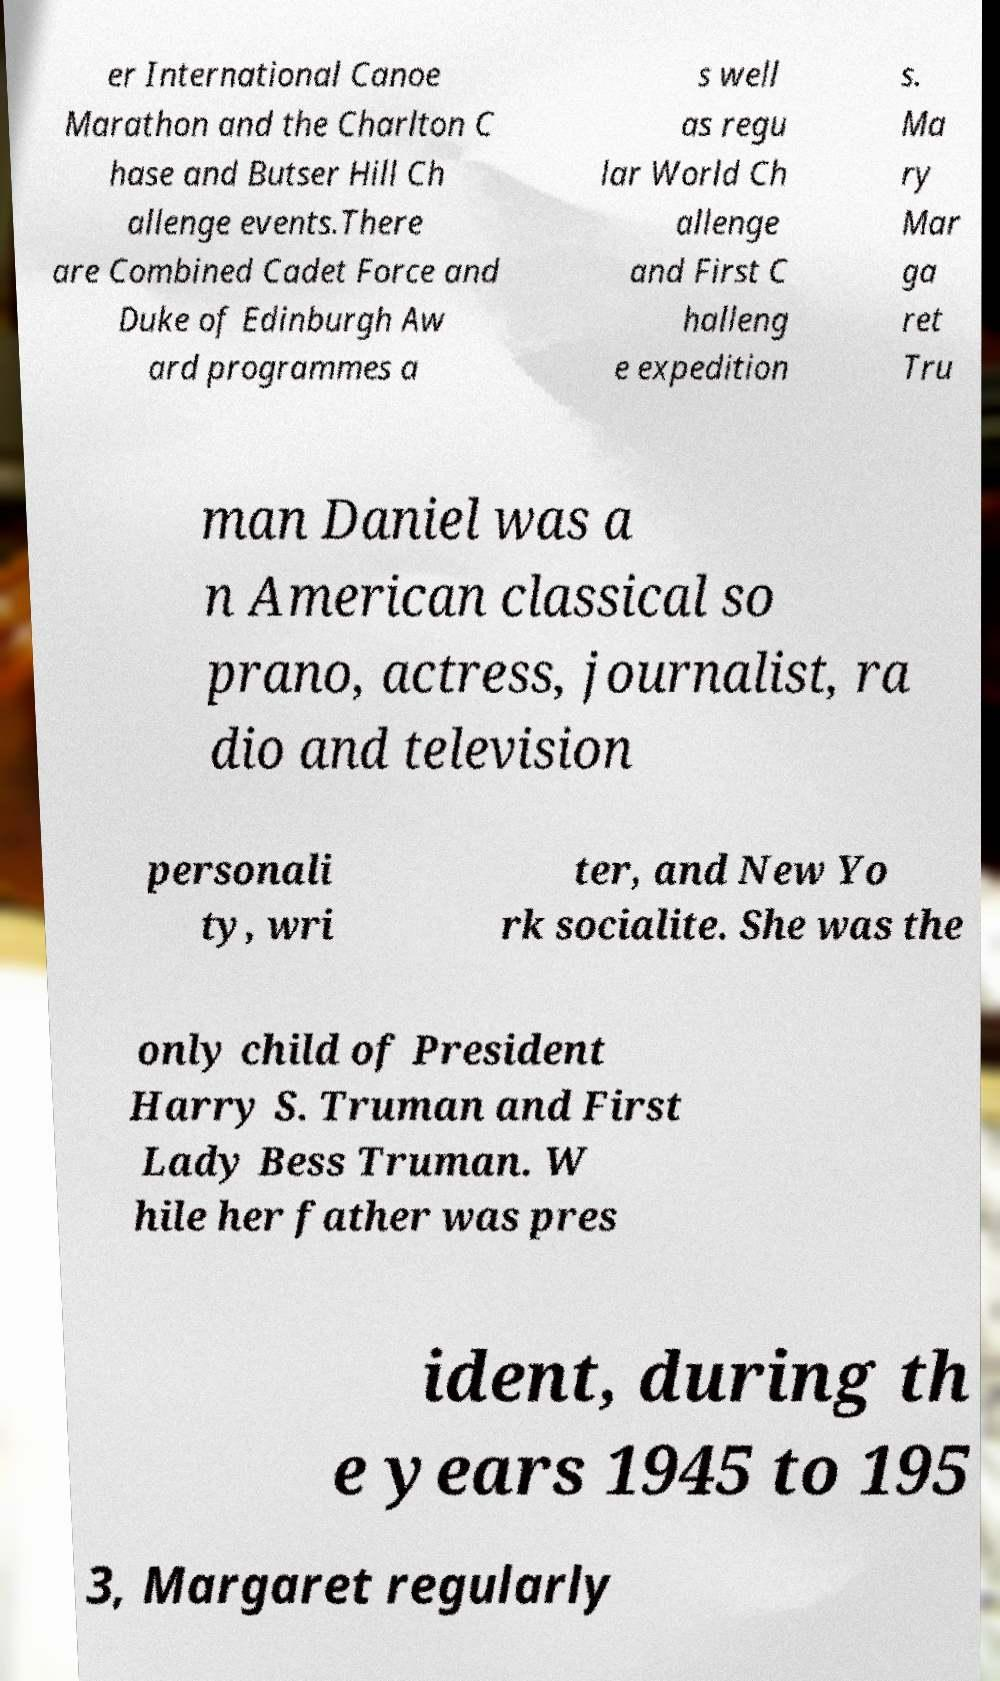What messages or text are displayed in this image? I need them in a readable, typed format. er International Canoe Marathon and the Charlton C hase and Butser Hill Ch allenge events.There are Combined Cadet Force and Duke of Edinburgh Aw ard programmes a s well as regu lar World Ch allenge and First C halleng e expedition s. Ma ry Mar ga ret Tru man Daniel was a n American classical so prano, actress, journalist, ra dio and television personali ty, wri ter, and New Yo rk socialite. She was the only child of President Harry S. Truman and First Lady Bess Truman. W hile her father was pres ident, during th e years 1945 to 195 3, Margaret regularly 